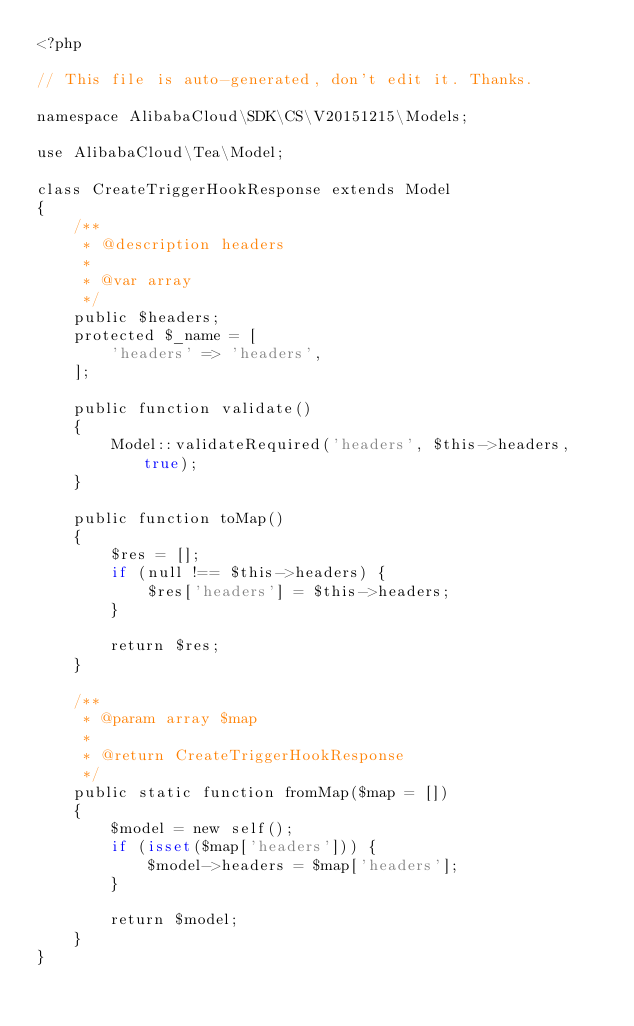Convert code to text. <code><loc_0><loc_0><loc_500><loc_500><_PHP_><?php

// This file is auto-generated, don't edit it. Thanks.

namespace AlibabaCloud\SDK\CS\V20151215\Models;

use AlibabaCloud\Tea\Model;

class CreateTriggerHookResponse extends Model
{
    /**
     * @description headers
     *
     * @var array
     */
    public $headers;
    protected $_name = [
        'headers' => 'headers',
    ];

    public function validate()
    {
        Model::validateRequired('headers', $this->headers, true);
    }

    public function toMap()
    {
        $res = [];
        if (null !== $this->headers) {
            $res['headers'] = $this->headers;
        }

        return $res;
    }

    /**
     * @param array $map
     *
     * @return CreateTriggerHookResponse
     */
    public static function fromMap($map = [])
    {
        $model = new self();
        if (isset($map['headers'])) {
            $model->headers = $map['headers'];
        }

        return $model;
    }
}
</code> 